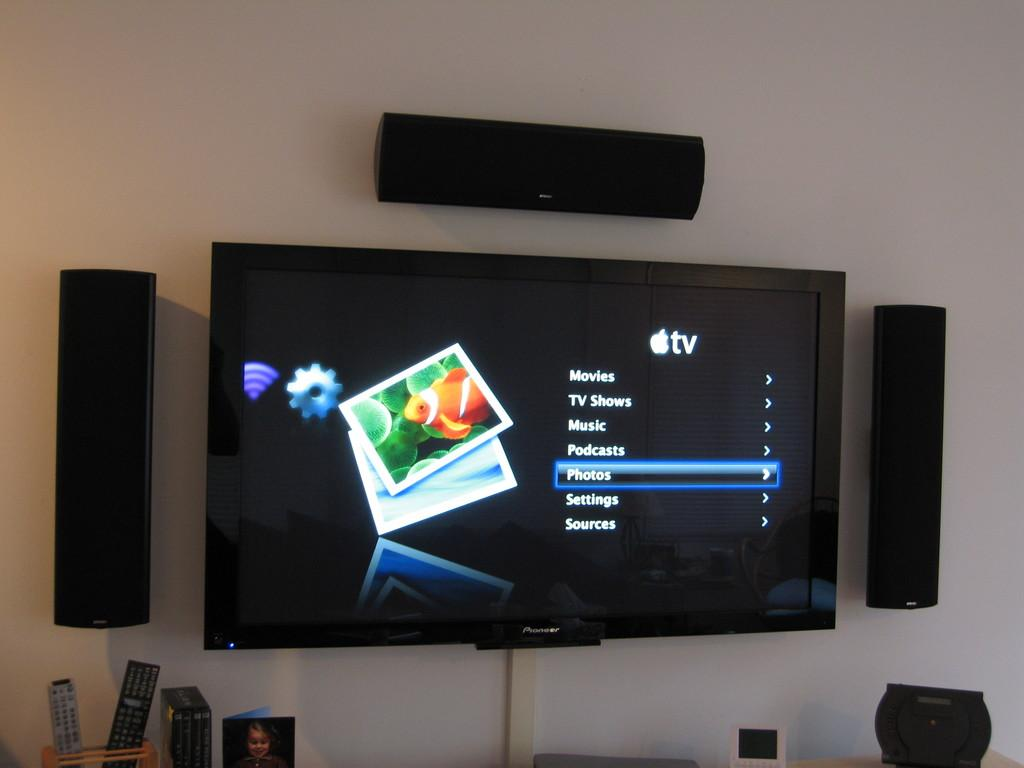<image>
Share a concise interpretation of the image provided. A television screen with the list item Photos selected. 